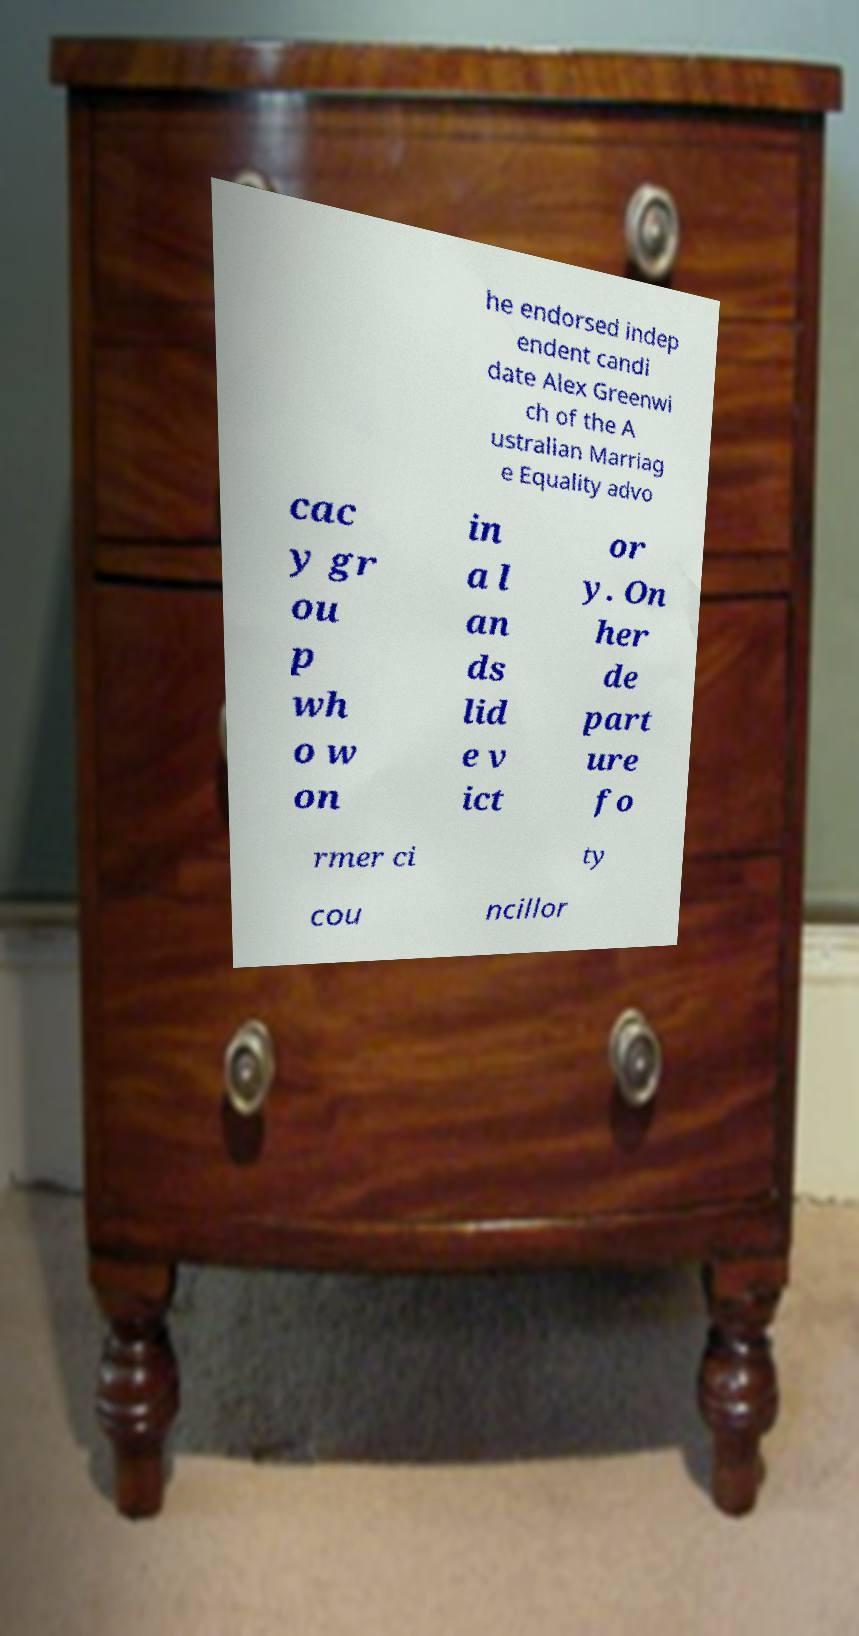There's text embedded in this image that I need extracted. Can you transcribe it verbatim? he endorsed indep endent candi date Alex Greenwi ch of the A ustralian Marriag e Equality advo cac y gr ou p wh o w on in a l an ds lid e v ict or y. On her de part ure fo rmer ci ty cou ncillor 